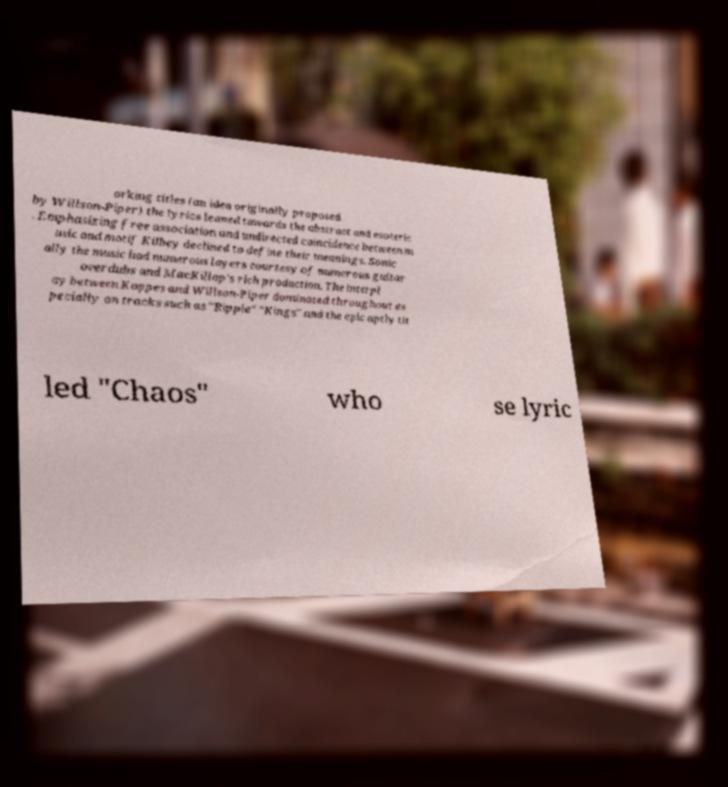What messages or text are displayed in this image? I need them in a readable, typed format. orking titles (an idea originally proposed by Willson-Piper) the lyrics leaned towards the abstract and esoteric . Emphasizing free association and undirected coincidence between m usic and motif Kilbey declined to define their meanings. Sonic ally the music had numerous layers courtesy of numerous guitar overdubs and MacKillop's rich production. The interpl ay between Koppes and Willson-Piper dominated throughout es pecially on tracks such as "Ripple" "Kings" and the epic aptly tit led "Chaos" who se lyric 